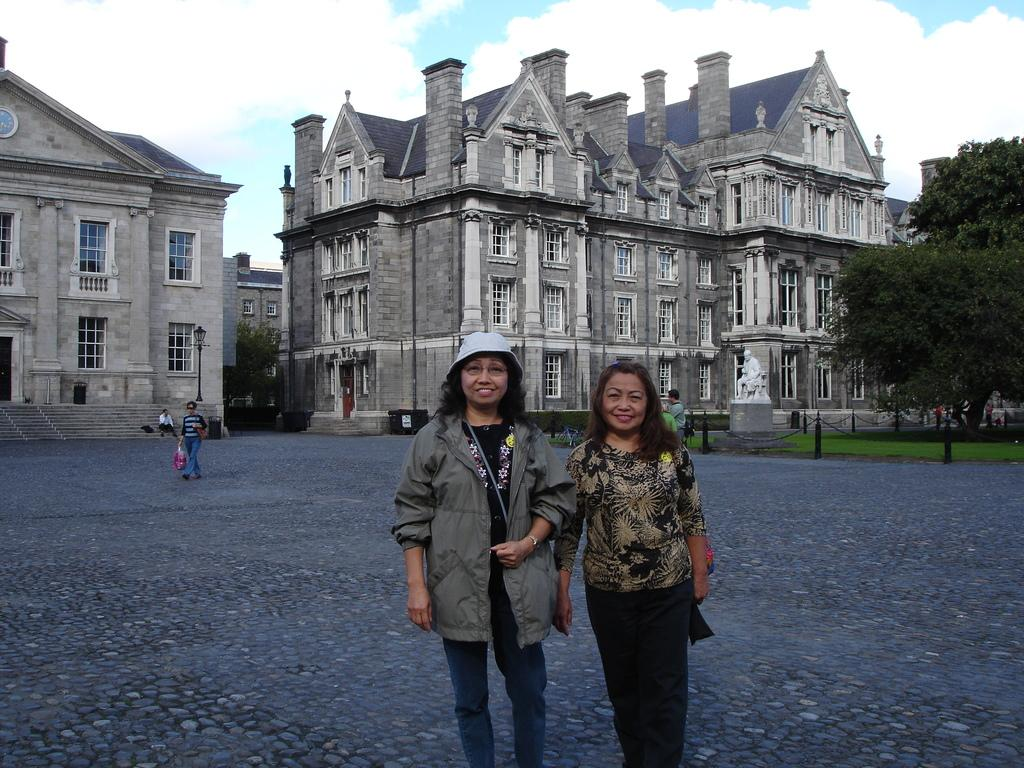How many people are in the image? There are two people standing and smiling in the image. What can be seen in the background of the image? Buildings, glass windows, stairs, a white statue, fencing, and trees are visible in the background. What is the color of the sky in the image? The sky is blue and white in color. What type of crate is being used for arithmetic in the image? There is no crate or arithmetic present in the image. What kind of hat is the person wearing in the image? Neither person in the image is wearing a hat. 